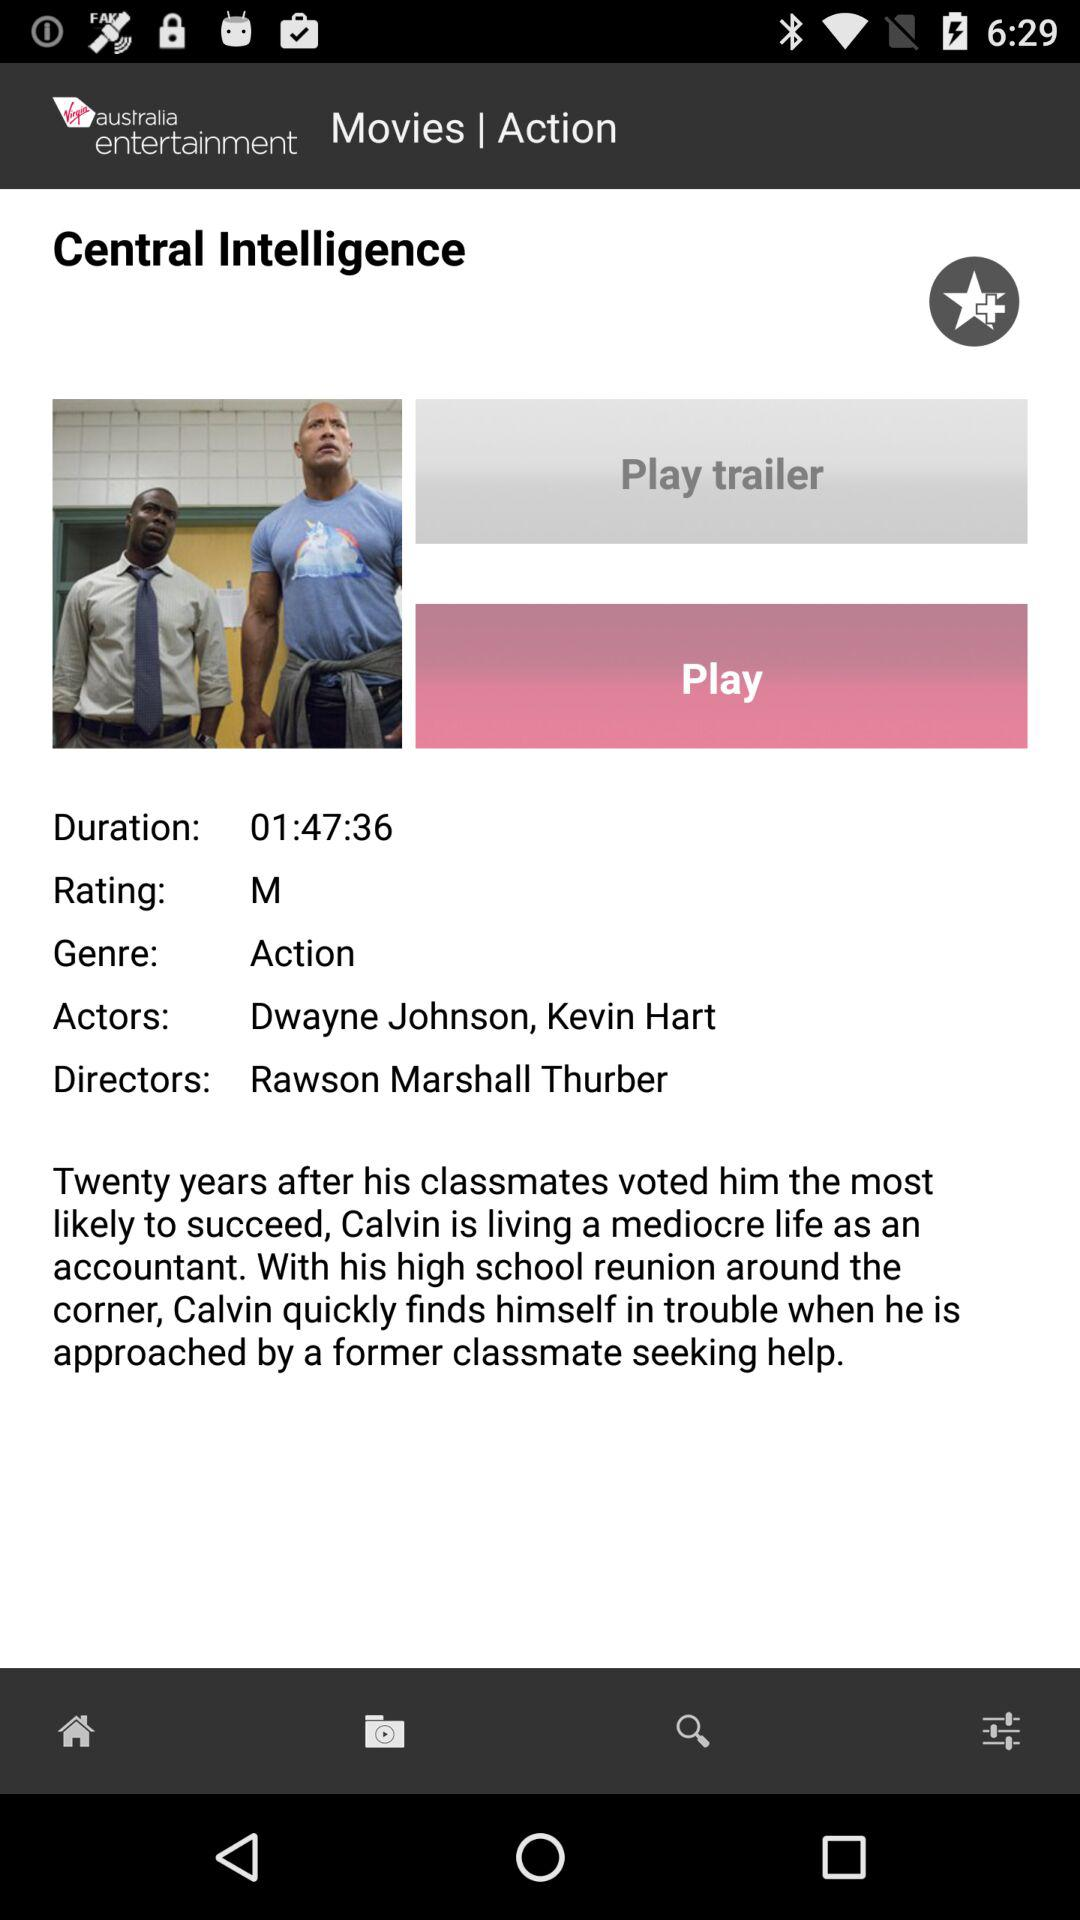What is the rating of the movie? The rating of the movie is M. 